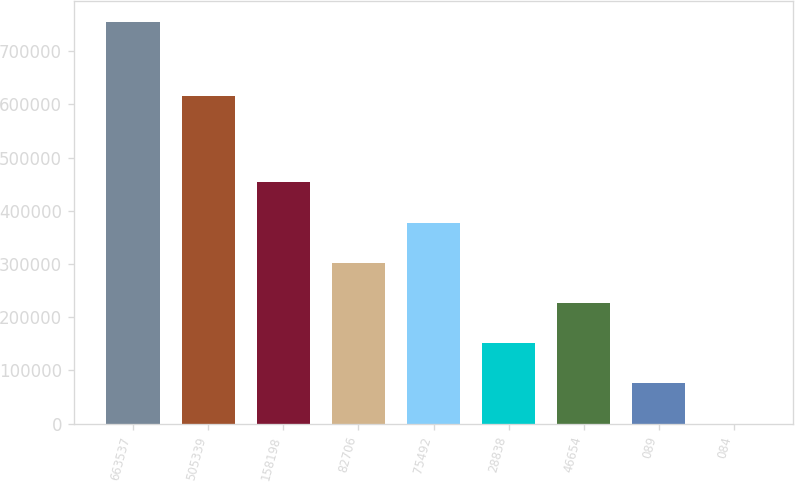Convert chart. <chart><loc_0><loc_0><loc_500><loc_500><bar_chart><fcel>663537<fcel>505339<fcel>158198<fcel>82706<fcel>75492<fcel>28838<fcel>46654<fcel>089<fcel>084<nl><fcel>755723<fcel>615090<fcel>453434<fcel>302290<fcel>377862<fcel>151145<fcel>226718<fcel>75573.1<fcel>0.88<nl></chart> 